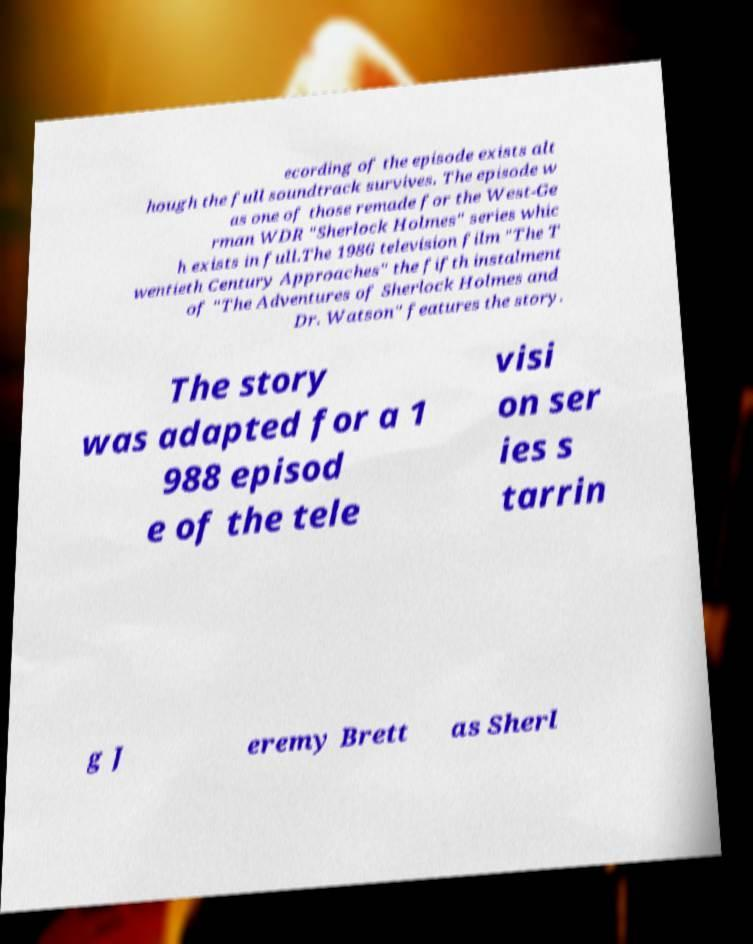There's text embedded in this image that I need extracted. Can you transcribe it verbatim? ecording of the episode exists alt hough the full soundtrack survives. The episode w as one of those remade for the West-Ge rman WDR "Sherlock Holmes" series whic h exists in full.The 1986 television film "The T wentieth Century Approaches" the fifth instalment of "The Adventures of Sherlock Holmes and Dr. Watson" features the story. The story was adapted for a 1 988 episod e of the tele visi on ser ies s tarrin g J eremy Brett as Sherl 